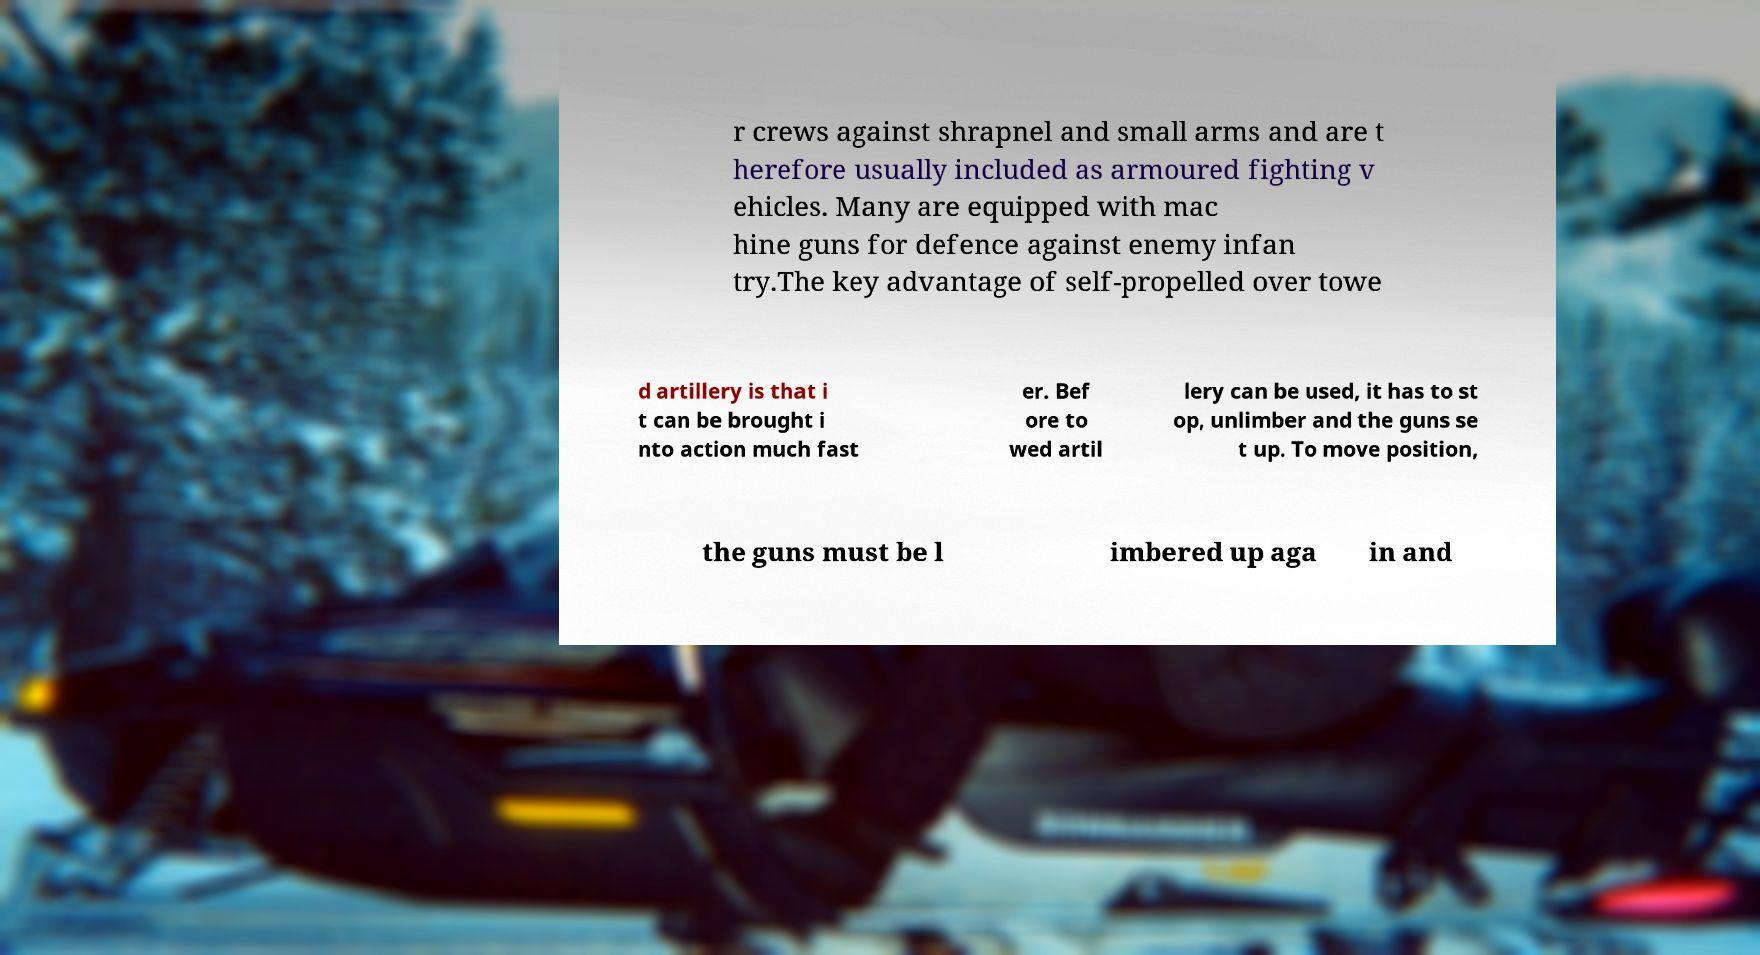Can you accurately transcribe the text from the provided image for me? r crews against shrapnel and small arms and are t herefore usually included as armoured fighting v ehicles. Many are equipped with mac hine guns for defence against enemy infan try.The key advantage of self-propelled over towe d artillery is that i t can be brought i nto action much fast er. Bef ore to wed artil lery can be used, it has to st op, unlimber and the guns se t up. To move position, the guns must be l imbered up aga in and 